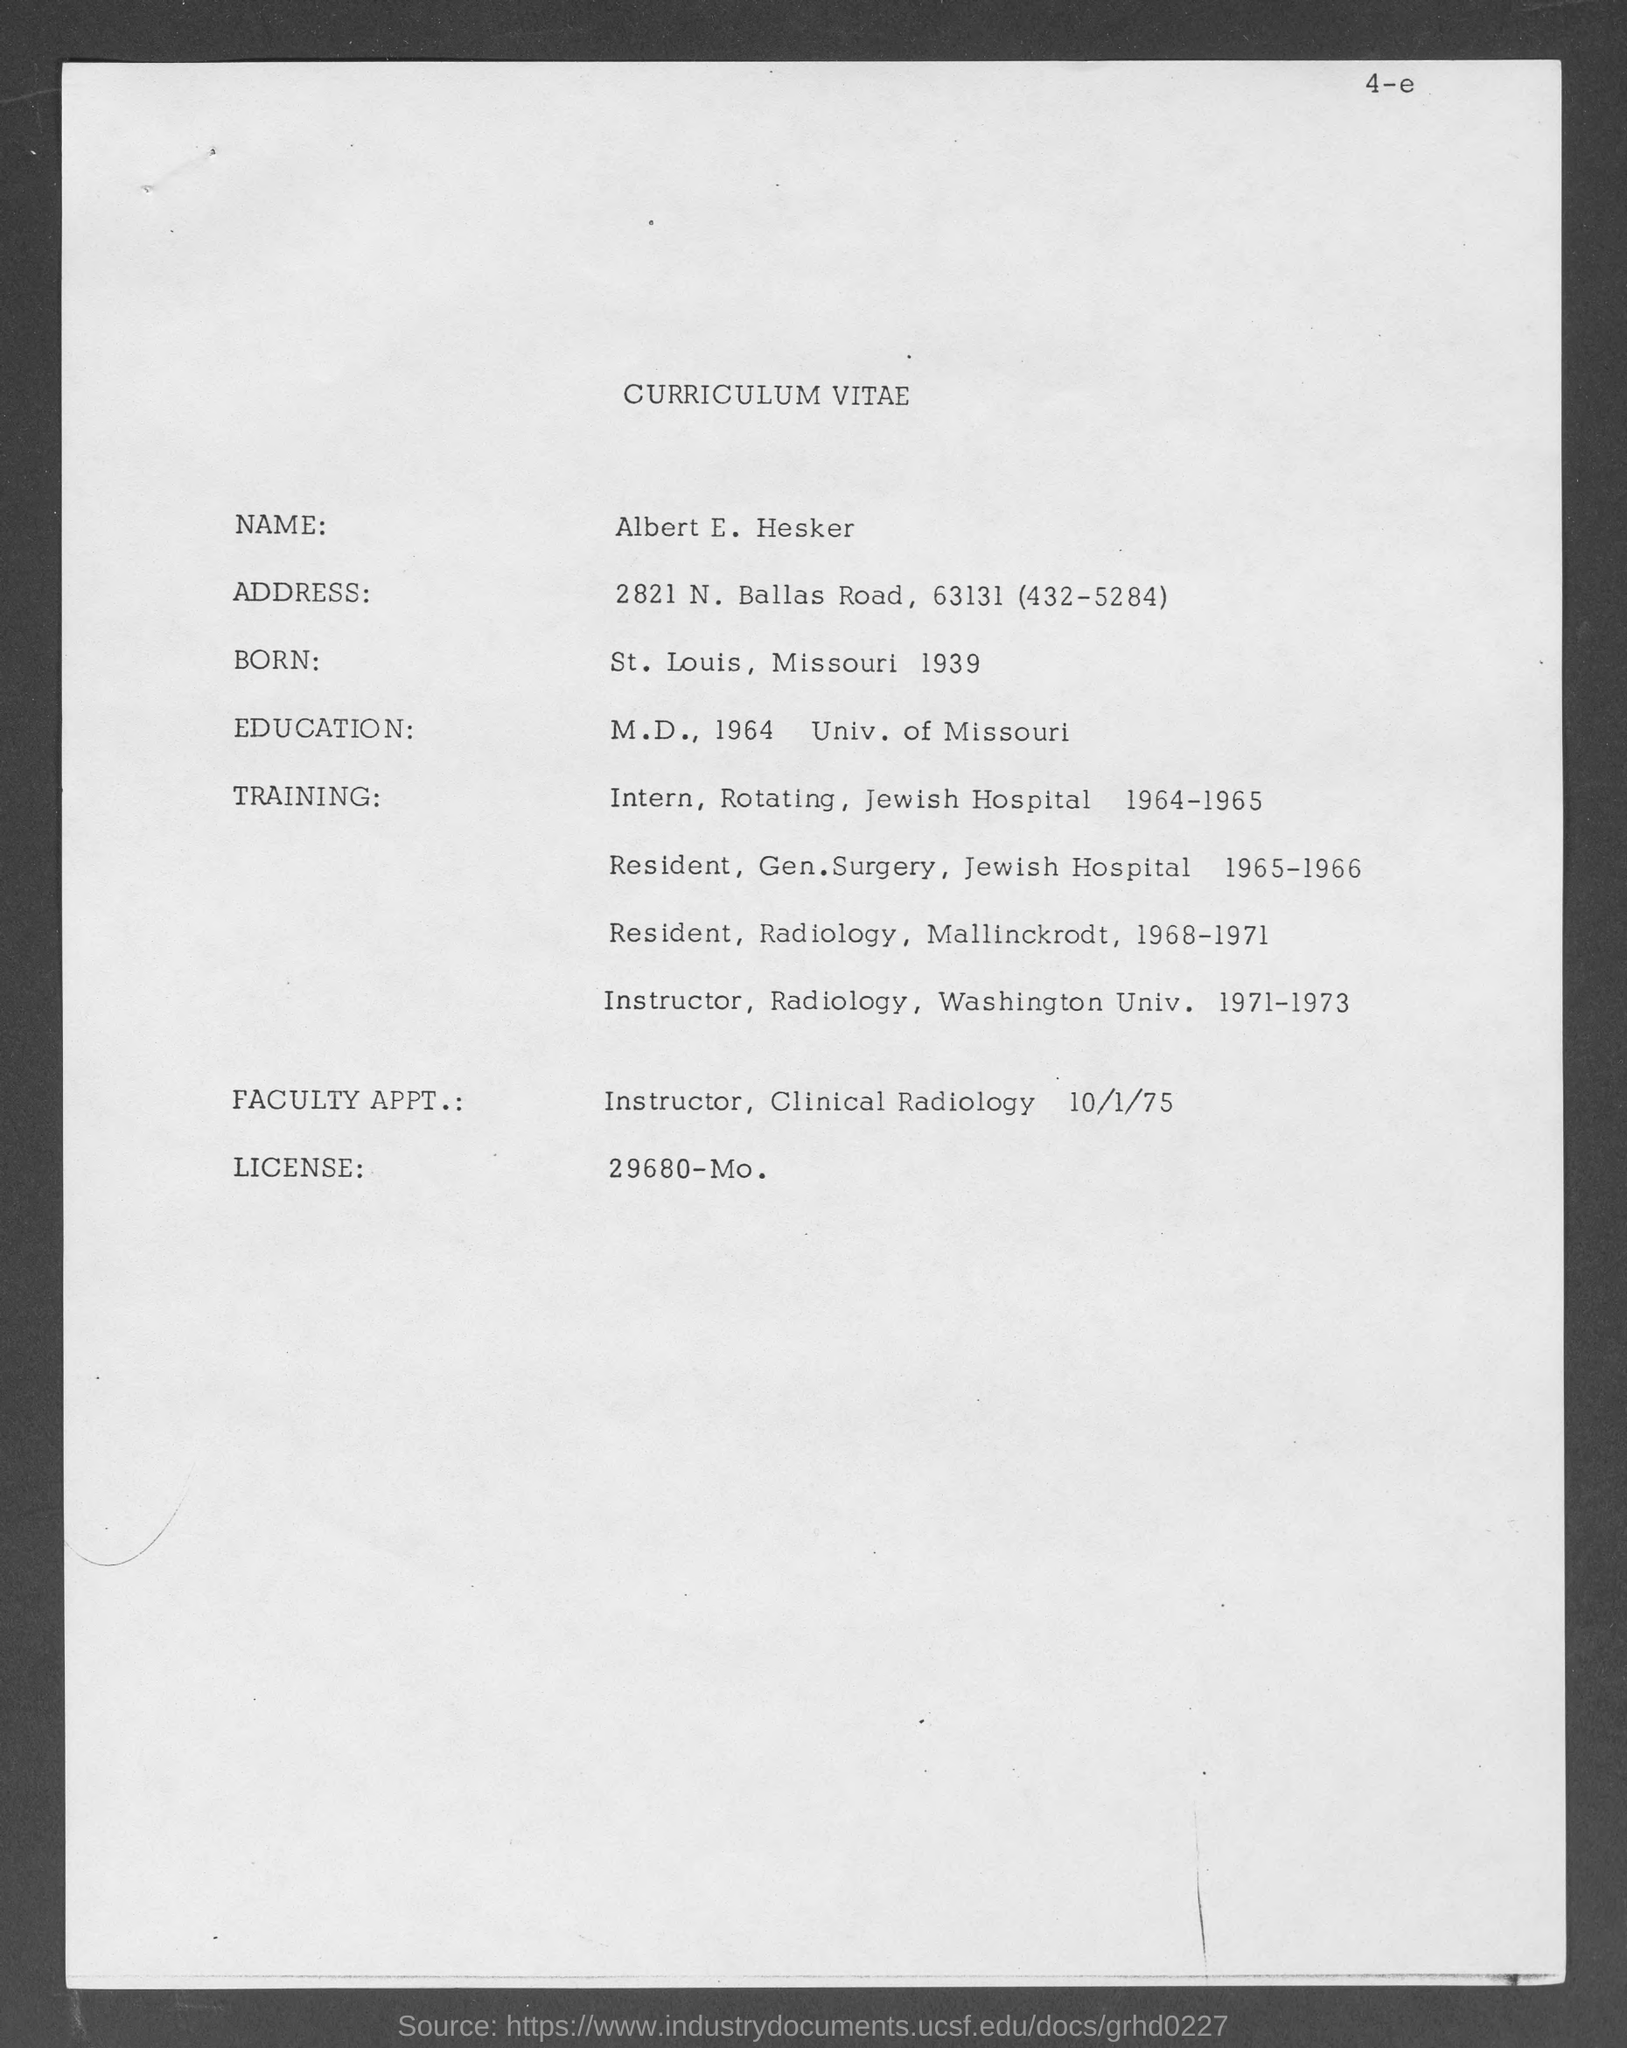List a handful of essential elements in this visual. The license number of Albert is 29680-Mo... The curriculum vitae of Albert E. Hesker is provided. Albert holds a Doctor of Medicine (M.D.) degree. 